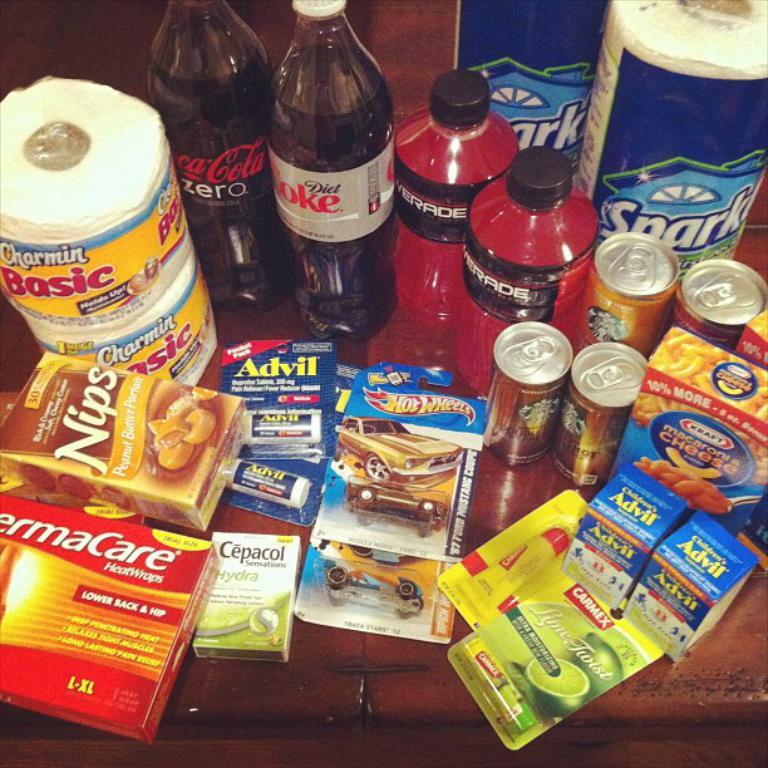<image>
Describe the image concisely. Many medicine on a table including one that says Advil. 